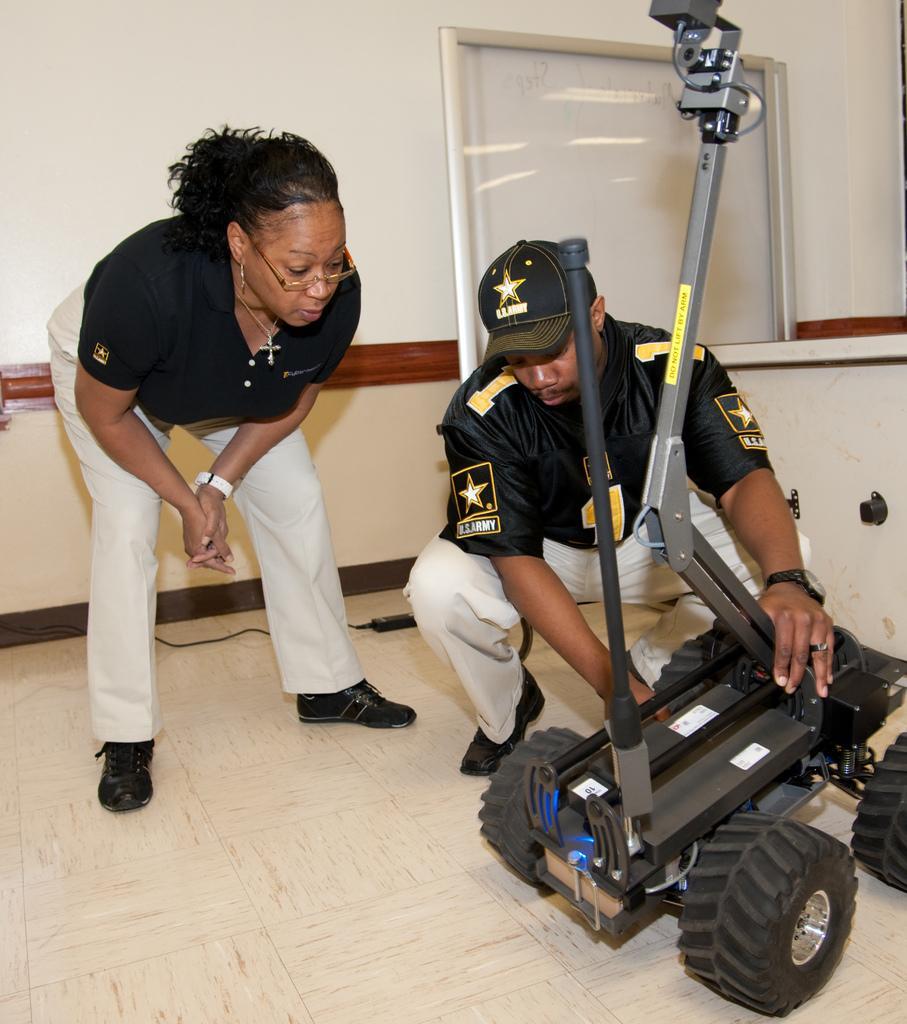Describe this image in one or two sentences. In this picture we can see a man is in squat position and holding an object and to the object there are wheels. On the left side of the man there is a woman standing on the floor. Behind the people there is a cable, wall and an object. 